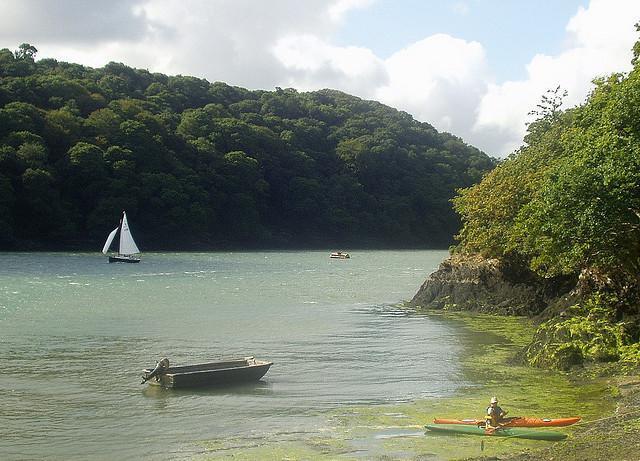How many sailboats are there?
Give a very brief answer. 1. How many boats are there?
Give a very brief answer. 4. 